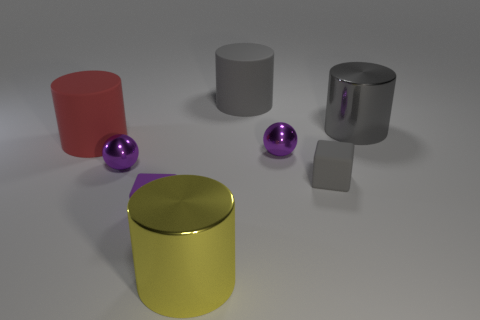Are the red cylinder behind the purple rubber thing and the big yellow object made of the same material?
Your answer should be compact. No. What is the material of the gray cylinder that is left of the big gray metal cylinder?
Offer a very short reply. Rubber. There is a gray rubber object on the right side of the tiny purple sphere on the right side of the yellow metallic thing; how big is it?
Provide a short and direct response. Small. Is there a large gray thing made of the same material as the large red thing?
Make the answer very short. Yes. What is the shape of the small gray matte thing on the right side of the cylinder left of the big yellow cylinder right of the large red rubber thing?
Give a very brief answer. Cube. Is the color of the metallic cylinder that is right of the yellow cylinder the same as the large thing on the left side of the yellow shiny object?
Keep it short and to the point. No. There is a red rubber thing; are there any large shiny cylinders behind it?
Provide a succinct answer. Yes. What number of big gray metal objects have the same shape as the purple matte thing?
Offer a very short reply. 0. There is a shiny object left of the big yellow metallic thing that is in front of the gray cylinder that is left of the gray shiny thing; what color is it?
Offer a terse response. Purple. Does the gray cylinder left of the large gray metal cylinder have the same material as the block that is in front of the gray matte cube?
Offer a very short reply. Yes. 